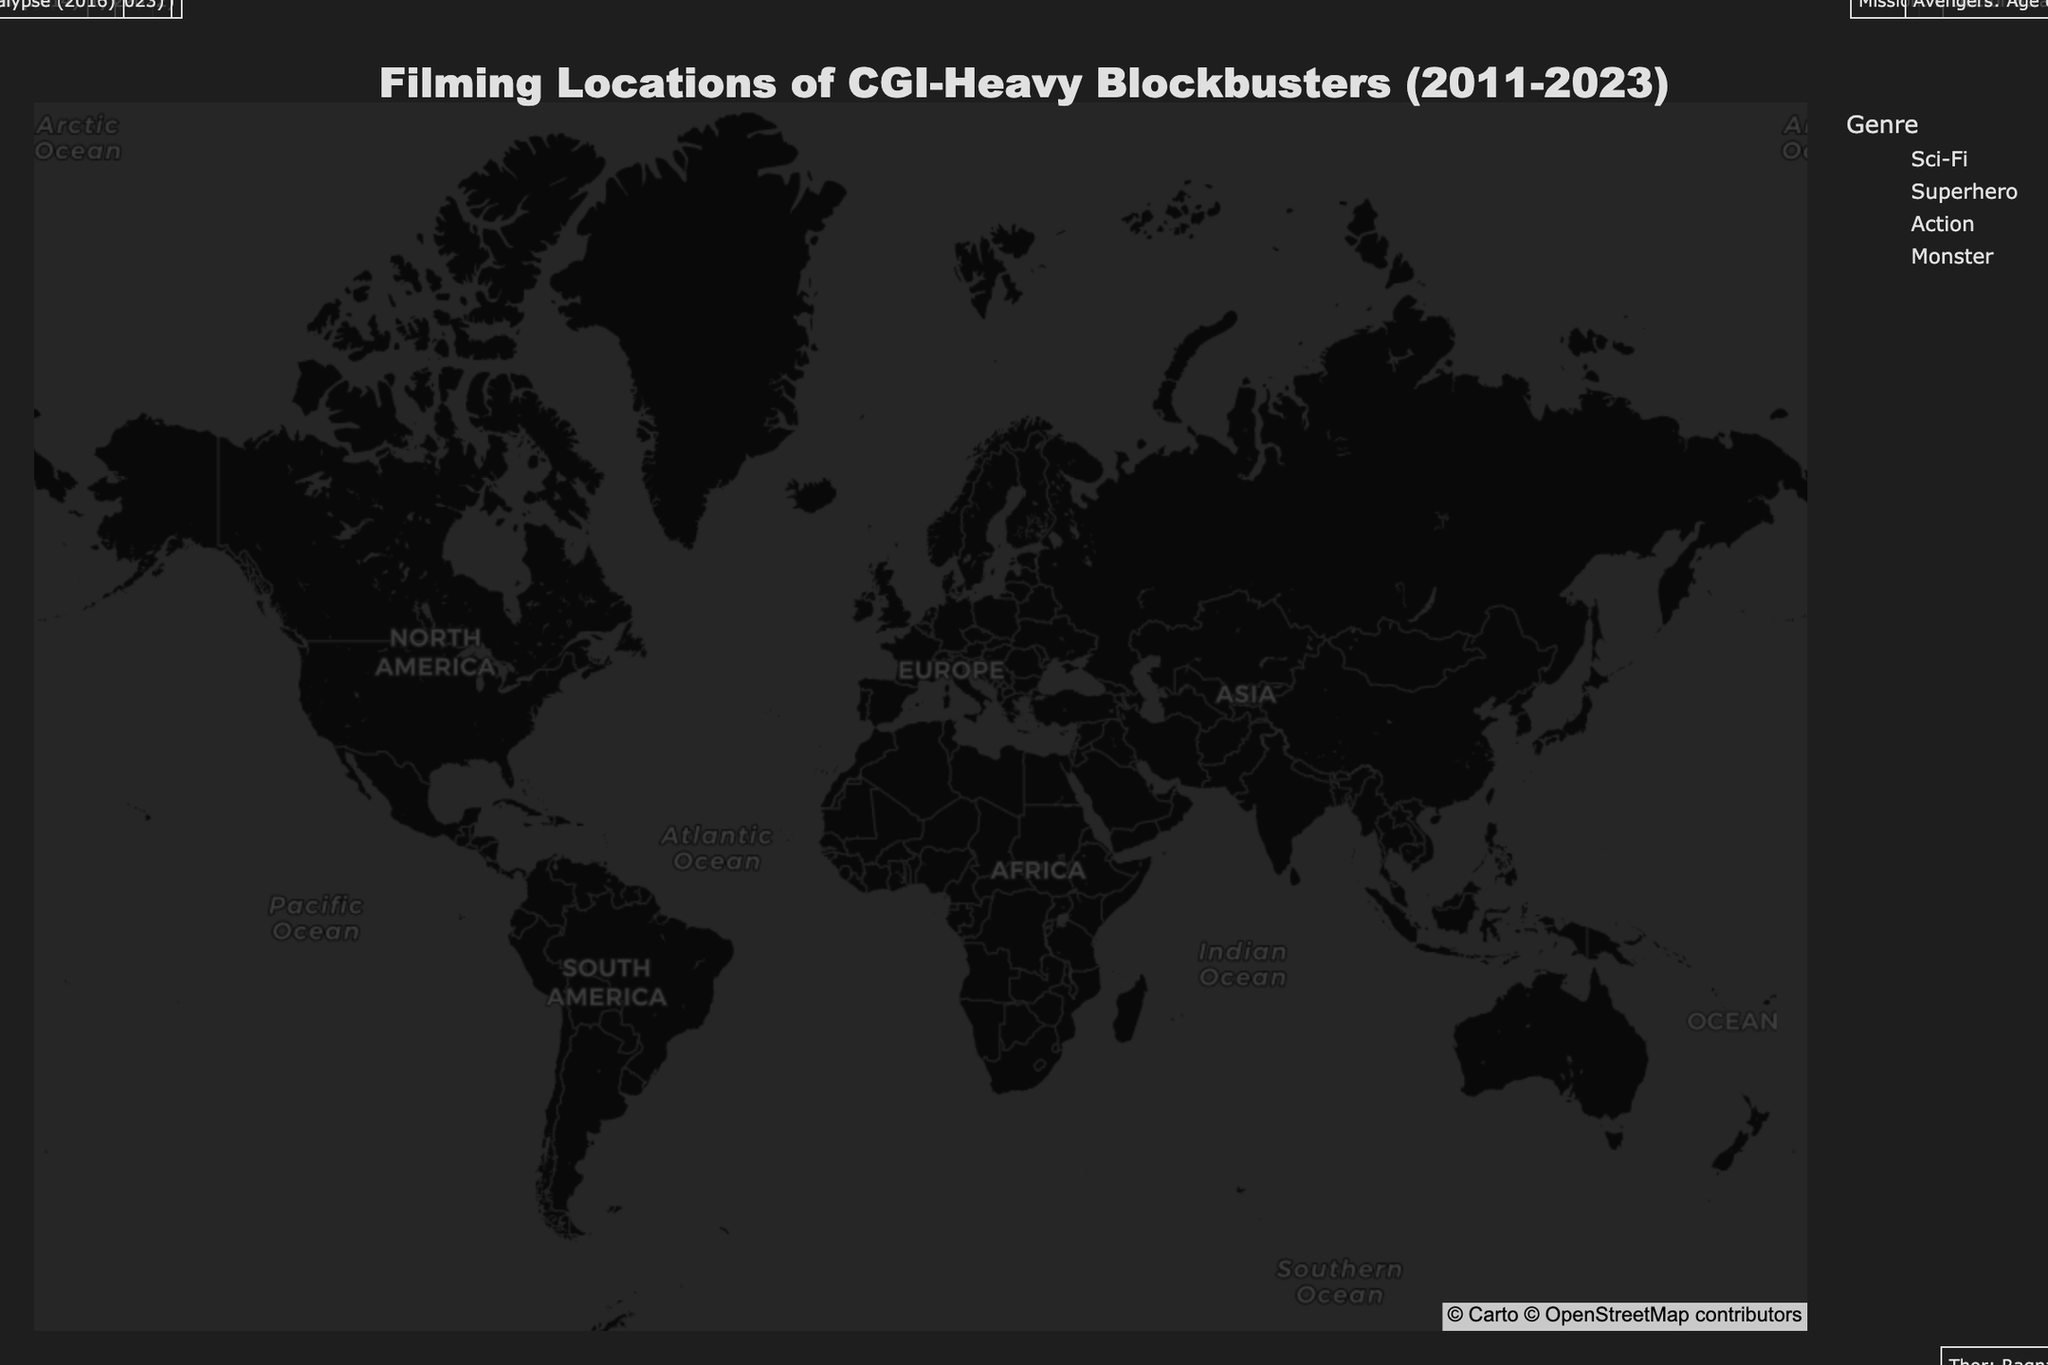What genre is the most common among the filming locations? By looking at the colors representing different genres, it's evident which genre has the most points. In this figure, the Superhero genre appears more frequently than the others.
Answer: Superhero Which city has the filming location for the movie "Mad Max: Fury Road"? Locate the annotation for "Mad Max: Fury Road" on the map, which will be pointing to the city where it was filmed. The annotation points to Sydney.
Answer: Sydney How many filming locations are there in Europe? By identifying and counting the points located in Europe, there are four: London, Budapest, Prague, and Reykjavik.
Answer: Four What year is associated with the filming location in Reykjavik? Find the annotation for Reykjavik and note the year in the parentheses. The annotation shows "Interstellar (2014)".
Answer: 2014 Which two cities have filming locations for movies released in 2021? Look for annotations with the year 2021. They appear in Vancouver for "Godzilla vs. Kong" and in Budapest for "Dune".
Answer: Vancouver and Budapest What is the latitude and longitude of the filming location for "Doctor Strange"? The annotation for "Doctor Strange" points to Prague. Check Prague's coordinates from the data provided.
Answer: 50.0755, 14.4378 Comparing "Avengers: Age of Ultron" and "Thor: Ragnarok", which movie's filming location is further east? Compare the longitudes of both places. Seoul (-126.9780) and Gold Coast (153.4000), Gold Coast is further east.
Answer: Thor: Ragnarok What is the average latitude of the Sci-Fi genre filming locations? Sum the latitudes of the Sci-Fi locations (41.2924, 51.5074, 47.4979, 64.1265) and divide by the number of these locations (4). Calculation: (41.2924 + 51.5074 + 47.4979 + 64.1265) / 4 = 51.60605
Answer: 51.60605 Which filming location is closest to the equator? The equator has a latitude of 0. The closer to zero, the closer to the equator. Dubai (25.2048) is nearest compared to other locations.
Answer: Dubai What is the northernmost filming location for a Superhero genre movie? Look for the highest latitude among the Superhero genre locations. Montreal (latitude 45.5017) is the northernmost location.
Answer: Montreal 